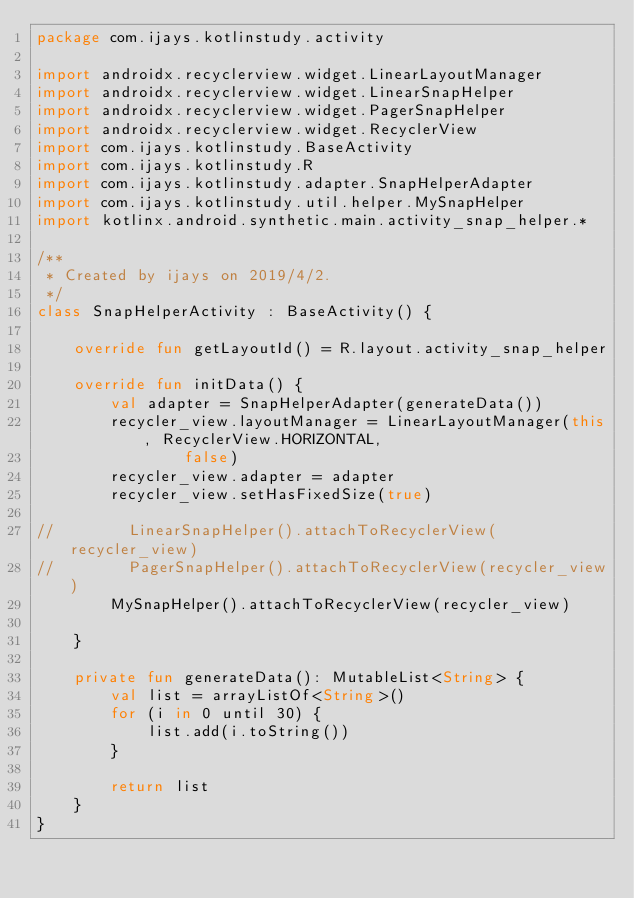<code> <loc_0><loc_0><loc_500><loc_500><_Kotlin_>package com.ijays.kotlinstudy.activity

import androidx.recyclerview.widget.LinearLayoutManager
import androidx.recyclerview.widget.LinearSnapHelper
import androidx.recyclerview.widget.PagerSnapHelper
import androidx.recyclerview.widget.RecyclerView
import com.ijays.kotlinstudy.BaseActivity
import com.ijays.kotlinstudy.R
import com.ijays.kotlinstudy.adapter.SnapHelperAdapter
import com.ijays.kotlinstudy.util.helper.MySnapHelper
import kotlinx.android.synthetic.main.activity_snap_helper.*

/**
 * Created by ijays on 2019/4/2.
 */
class SnapHelperActivity : BaseActivity() {

    override fun getLayoutId() = R.layout.activity_snap_helper

    override fun initData() {
        val adapter = SnapHelperAdapter(generateData())
        recycler_view.layoutManager = LinearLayoutManager(this, RecyclerView.HORIZONTAL,
                false)
        recycler_view.adapter = adapter
        recycler_view.setHasFixedSize(true)

//        LinearSnapHelper().attachToRecyclerView(recycler_view)
//        PagerSnapHelper().attachToRecyclerView(recycler_view)
        MySnapHelper().attachToRecyclerView(recycler_view)

    }

    private fun generateData(): MutableList<String> {
        val list = arrayListOf<String>()
        for (i in 0 until 30) {
            list.add(i.toString())
        }

        return list
    }
}</code> 